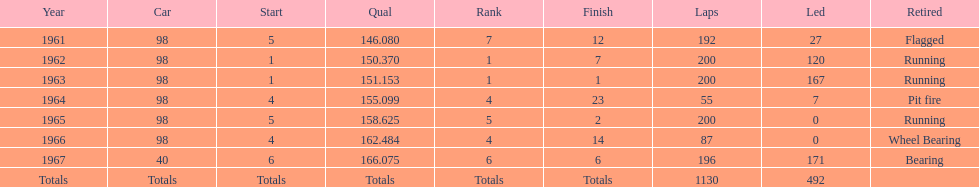How many total laps have been driven in the indy 500? 1130. 